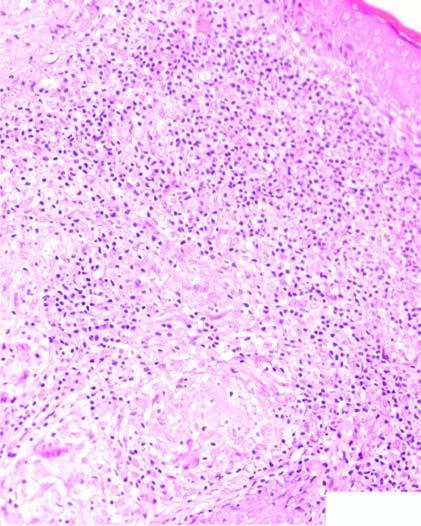does the dermis contain caseating epithelioid cell granulomas having giant cells and lymphocytes?
Answer the question using a single word or phrase. Yes 